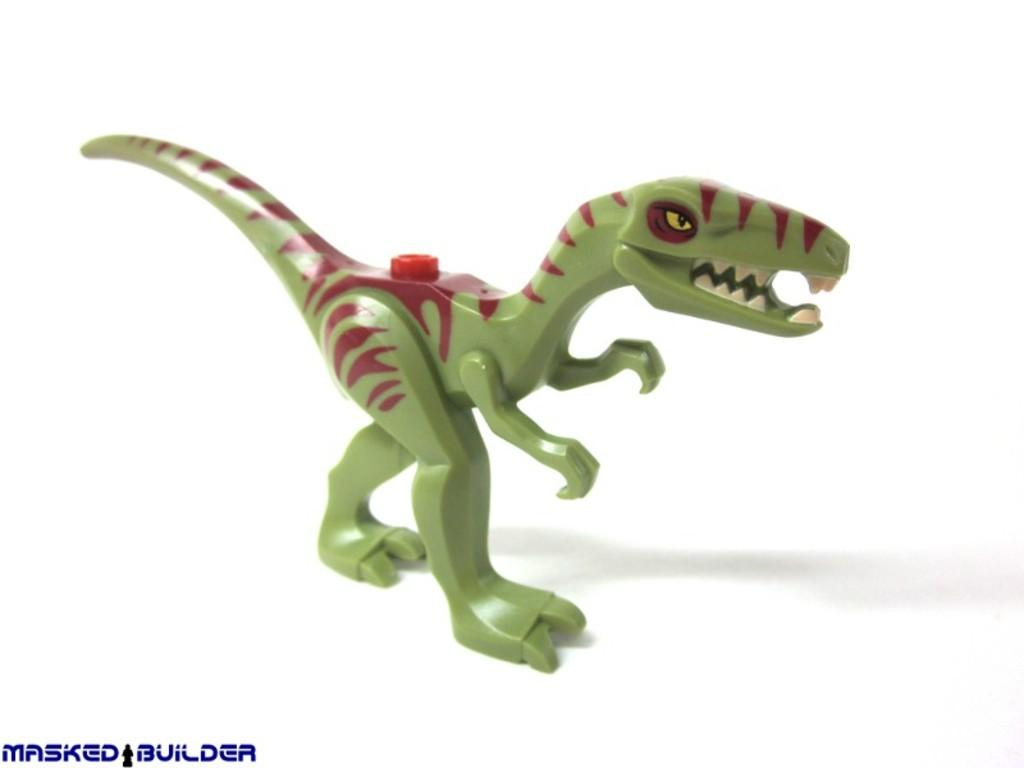What is the main subject in the image? There is a toy in the image. What colors are used for the toy? The toy is in red and green colors. What is the color of the surface on which the toy is placed? The toy is on a white surface. What type of yam is being used to play a match with the toy in the image? There is no yam or match present in the image; it features a toy on a white surface. 